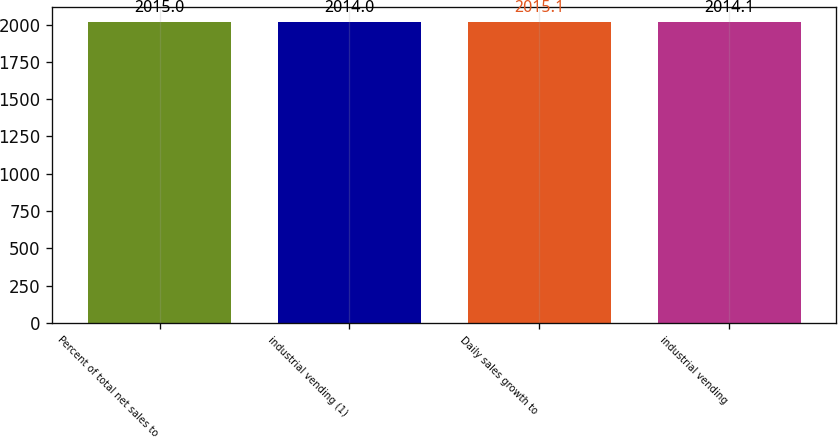Convert chart. <chart><loc_0><loc_0><loc_500><loc_500><bar_chart><fcel>Percent of total net sales to<fcel>industrial vending (1)<fcel>Daily sales growth to<fcel>industrial vending<nl><fcel>2015<fcel>2014<fcel>2015.1<fcel>2014.1<nl></chart> 